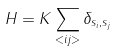Convert formula to latex. <formula><loc_0><loc_0><loc_500><loc_500>H = K \sum _ { < i j > } \delta _ { s _ { i } , s _ { j } }</formula> 